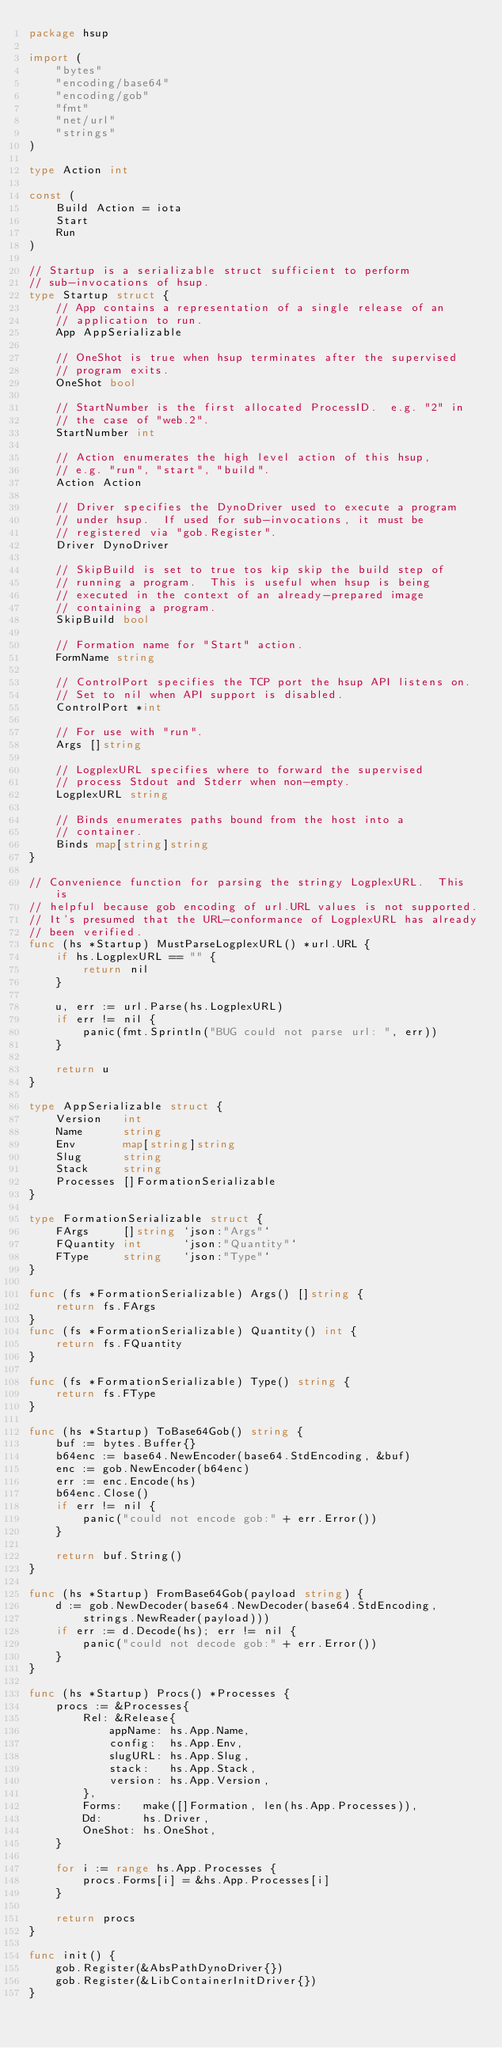<code> <loc_0><loc_0><loc_500><loc_500><_Go_>package hsup

import (
	"bytes"
	"encoding/base64"
	"encoding/gob"
	"fmt"
	"net/url"
	"strings"
)

type Action int

const (
	Build Action = iota
	Start
	Run
)

// Startup is a serializable struct sufficient to perform
// sub-invocations of hsup.
type Startup struct {
	// App contains a representation of a single release of an
	// application to run.
	App AppSerializable

	// OneShot is true when hsup terminates after the supervised
	// program exits.
	OneShot bool

	// StartNumber is the first allocated ProcessID.  e.g. "2" in
	// the case of "web.2".
	StartNumber int

	// Action enumerates the high level action of this hsup,
	// e.g. "run", "start", "build".
	Action Action

	// Driver specifies the DynoDriver used to execute a program
	// under hsup.  If used for sub-invocations, it must be
	// registered via "gob.Register".
	Driver DynoDriver

	// SkipBuild is set to true tos kip skip the build step of
	// running a program.  This is useful when hsup is being
	// executed in the context of an already-prepared image
	// containing a program.
	SkipBuild bool

	// Formation name for "Start" action.
	FormName string

	// ControlPort specifies the TCP port the hsup API listens on.
	// Set to nil when API support is disabled.
	ControlPort *int

	// For use with "run".
	Args []string

	// LogplexURL specifies where to forward the supervised
	// process Stdout and Stderr when non-empty.
	LogplexURL string

	// Binds enumerates paths bound from the host into a
	// container.
	Binds map[string]string
}

// Convenience function for parsing the stringy LogplexURL.  This is
// helpful because gob encoding of url.URL values is not supported.
// It's presumed that the URL-conformance of LogplexURL has already
// been verified.
func (hs *Startup) MustParseLogplexURL() *url.URL {
	if hs.LogplexURL == "" {
		return nil
	}

	u, err := url.Parse(hs.LogplexURL)
	if err != nil {
		panic(fmt.Sprintln("BUG could not parse url: ", err))
	}

	return u
}

type AppSerializable struct {
	Version   int
	Name      string
	Env       map[string]string
	Slug      string
	Stack     string
	Processes []FormationSerializable
}

type FormationSerializable struct {
	FArgs     []string `json:"Args"`
	FQuantity int      `json:"Quantity"`
	FType     string   `json:"Type"`
}

func (fs *FormationSerializable) Args() []string {
	return fs.FArgs
}
func (fs *FormationSerializable) Quantity() int {
	return fs.FQuantity
}

func (fs *FormationSerializable) Type() string {
	return fs.FType
}

func (hs *Startup) ToBase64Gob() string {
	buf := bytes.Buffer{}
	b64enc := base64.NewEncoder(base64.StdEncoding, &buf)
	enc := gob.NewEncoder(b64enc)
	err := enc.Encode(hs)
	b64enc.Close()
	if err != nil {
		panic("could not encode gob:" + err.Error())
	}

	return buf.String()
}

func (hs *Startup) FromBase64Gob(payload string) {
	d := gob.NewDecoder(base64.NewDecoder(base64.StdEncoding,
		strings.NewReader(payload)))
	if err := d.Decode(hs); err != nil {
		panic("could not decode gob:" + err.Error())
	}
}

func (hs *Startup) Procs() *Processes {
	procs := &Processes{
		Rel: &Release{
			appName: hs.App.Name,
			config:  hs.App.Env,
			slugURL: hs.App.Slug,
			stack:   hs.App.Stack,
			version: hs.App.Version,
		},
		Forms:   make([]Formation, len(hs.App.Processes)),
		Dd:      hs.Driver,
		OneShot: hs.OneShot,
	}

	for i := range hs.App.Processes {
		procs.Forms[i] = &hs.App.Processes[i]
	}

	return procs
}

func init() {
	gob.Register(&AbsPathDynoDriver{})
	gob.Register(&LibContainerInitDriver{})
}
</code> 